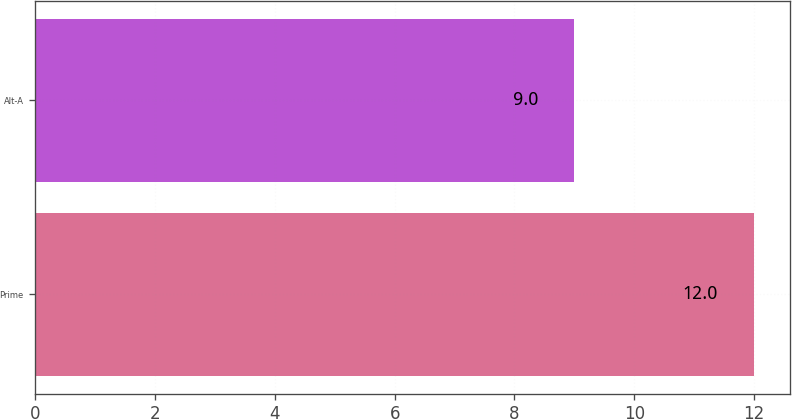<chart> <loc_0><loc_0><loc_500><loc_500><bar_chart><fcel>Prime<fcel>Alt-A<nl><fcel>12<fcel>9<nl></chart> 